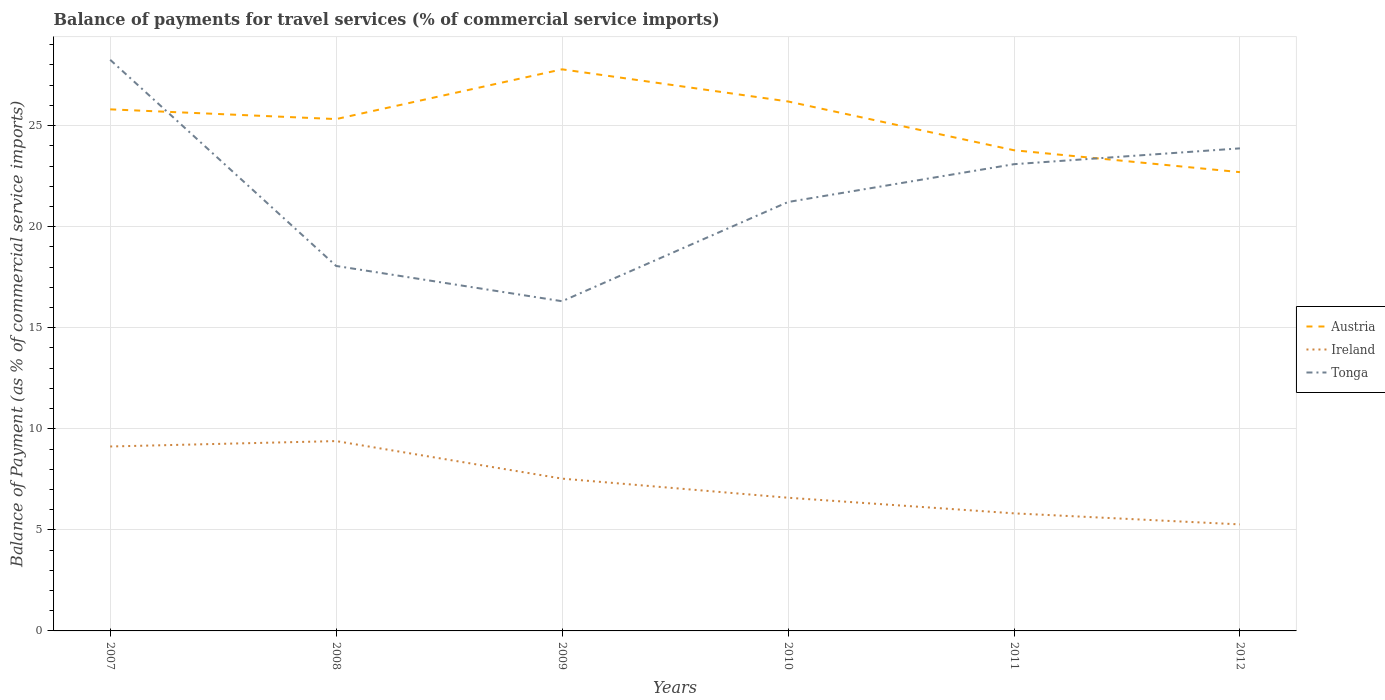Across all years, what is the maximum balance of payments for travel services in Ireland?
Your answer should be compact. 5.27. What is the total balance of payments for travel services in Austria in the graph?
Provide a succinct answer. 3.5. What is the difference between the highest and the second highest balance of payments for travel services in Austria?
Offer a terse response. 5.09. What is the difference between the highest and the lowest balance of payments for travel services in Austria?
Your response must be concise. 4. How many years are there in the graph?
Offer a terse response. 6. Are the values on the major ticks of Y-axis written in scientific E-notation?
Your answer should be compact. No. Does the graph contain any zero values?
Give a very brief answer. No. What is the title of the graph?
Your answer should be very brief. Balance of payments for travel services (% of commercial service imports). What is the label or title of the X-axis?
Your answer should be very brief. Years. What is the label or title of the Y-axis?
Make the answer very short. Balance of Payment (as % of commercial service imports). What is the Balance of Payment (as % of commercial service imports) in Austria in 2007?
Make the answer very short. 25.8. What is the Balance of Payment (as % of commercial service imports) in Ireland in 2007?
Give a very brief answer. 9.12. What is the Balance of Payment (as % of commercial service imports) of Tonga in 2007?
Provide a short and direct response. 28.25. What is the Balance of Payment (as % of commercial service imports) of Austria in 2008?
Offer a very short reply. 25.32. What is the Balance of Payment (as % of commercial service imports) in Ireland in 2008?
Ensure brevity in your answer.  9.39. What is the Balance of Payment (as % of commercial service imports) of Tonga in 2008?
Your answer should be very brief. 18.06. What is the Balance of Payment (as % of commercial service imports) of Austria in 2009?
Make the answer very short. 27.78. What is the Balance of Payment (as % of commercial service imports) of Ireland in 2009?
Ensure brevity in your answer.  7.53. What is the Balance of Payment (as % of commercial service imports) of Tonga in 2009?
Offer a very short reply. 16.31. What is the Balance of Payment (as % of commercial service imports) of Austria in 2010?
Offer a very short reply. 26.19. What is the Balance of Payment (as % of commercial service imports) of Ireland in 2010?
Make the answer very short. 6.59. What is the Balance of Payment (as % of commercial service imports) of Tonga in 2010?
Your answer should be very brief. 21.22. What is the Balance of Payment (as % of commercial service imports) of Austria in 2011?
Offer a terse response. 23.78. What is the Balance of Payment (as % of commercial service imports) of Ireland in 2011?
Give a very brief answer. 5.82. What is the Balance of Payment (as % of commercial service imports) in Tonga in 2011?
Keep it short and to the point. 23.09. What is the Balance of Payment (as % of commercial service imports) of Austria in 2012?
Provide a short and direct response. 22.7. What is the Balance of Payment (as % of commercial service imports) in Ireland in 2012?
Offer a very short reply. 5.27. What is the Balance of Payment (as % of commercial service imports) in Tonga in 2012?
Give a very brief answer. 23.87. Across all years, what is the maximum Balance of Payment (as % of commercial service imports) of Austria?
Your response must be concise. 27.78. Across all years, what is the maximum Balance of Payment (as % of commercial service imports) of Ireland?
Offer a very short reply. 9.39. Across all years, what is the maximum Balance of Payment (as % of commercial service imports) of Tonga?
Your response must be concise. 28.25. Across all years, what is the minimum Balance of Payment (as % of commercial service imports) in Austria?
Provide a short and direct response. 22.7. Across all years, what is the minimum Balance of Payment (as % of commercial service imports) in Ireland?
Make the answer very short. 5.27. Across all years, what is the minimum Balance of Payment (as % of commercial service imports) of Tonga?
Your answer should be compact. 16.31. What is the total Balance of Payment (as % of commercial service imports) in Austria in the graph?
Your answer should be very brief. 151.58. What is the total Balance of Payment (as % of commercial service imports) of Ireland in the graph?
Ensure brevity in your answer.  43.73. What is the total Balance of Payment (as % of commercial service imports) of Tonga in the graph?
Your response must be concise. 130.81. What is the difference between the Balance of Payment (as % of commercial service imports) in Austria in 2007 and that in 2008?
Make the answer very short. 0.48. What is the difference between the Balance of Payment (as % of commercial service imports) in Ireland in 2007 and that in 2008?
Offer a terse response. -0.27. What is the difference between the Balance of Payment (as % of commercial service imports) in Tonga in 2007 and that in 2008?
Your answer should be compact. 10.2. What is the difference between the Balance of Payment (as % of commercial service imports) in Austria in 2007 and that in 2009?
Offer a very short reply. -1.98. What is the difference between the Balance of Payment (as % of commercial service imports) of Ireland in 2007 and that in 2009?
Make the answer very short. 1.59. What is the difference between the Balance of Payment (as % of commercial service imports) in Tonga in 2007 and that in 2009?
Ensure brevity in your answer.  11.94. What is the difference between the Balance of Payment (as % of commercial service imports) in Austria in 2007 and that in 2010?
Offer a terse response. -0.39. What is the difference between the Balance of Payment (as % of commercial service imports) of Ireland in 2007 and that in 2010?
Your answer should be very brief. 2.54. What is the difference between the Balance of Payment (as % of commercial service imports) of Tonga in 2007 and that in 2010?
Provide a short and direct response. 7.03. What is the difference between the Balance of Payment (as % of commercial service imports) of Austria in 2007 and that in 2011?
Provide a succinct answer. 2.02. What is the difference between the Balance of Payment (as % of commercial service imports) in Ireland in 2007 and that in 2011?
Provide a succinct answer. 3.31. What is the difference between the Balance of Payment (as % of commercial service imports) in Tonga in 2007 and that in 2011?
Offer a terse response. 5.16. What is the difference between the Balance of Payment (as % of commercial service imports) of Austria in 2007 and that in 2012?
Offer a very short reply. 3.11. What is the difference between the Balance of Payment (as % of commercial service imports) in Ireland in 2007 and that in 2012?
Your answer should be compact. 3.85. What is the difference between the Balance of Payment (as % of commercial service imports) in Tonga in 2007 and that in 2012?
Provide a short and direct response. 4.38. What is the difference between the Balance of Payment (as % of commercial service imports) of Austria in 2008 and that in 2009?
Make the answer very short. -2.46. What is the difference between the Balance of Payment (as % of commercial service imports) of Ireland in 2008 and that in 2009?
Offer a very short reply. 1.86. What is the difference between the Balance of Payment (as % of commercial service imports) in Tonga in 2008 and that in 2009?
Provide a succinct answer. 1.74. What is the difference between the Balance of Payment (as % of commercial service imports) in Austria in 2008 and that in 2010?
Give a very brief answer. -0.87. What is the difference between the Balance of Payment (as % of commercial service imports) in Ireland in 2008 and that in 2010?
Make the answer very short. 2.8. What is the difference between the Balance of Payment (as % of commercial service imports) of Tonga in 2008 and that in 2010?
Offer a terse response. -3.16. What is the difference between the Balance of Payment (as % of commercial service imports) in Austria in 2008 and that in 2011?
Give a very brief answer. 1.54. What is the difference between the Balance of Payment (as % of commercial service imports) in Ireland in 2008 and that in 2011?
Give a very brief answer. 3.58. What is the difference between the Balance of Payment (as % of commercial service imports) of Tonga in 2008 and that in 2011?
Offer a terse response. -5.03. What is the difference between the Balance of Payment (as % of commercial service imports) of Austria in 2008 and that in 2012?
Keep it short and to the point. 2.63. What is the difference between the Balance of Payment (as % of commercial service imports) of Ireland in 2008 and that in 2012?
Keep it short and to the point. 4.12. What is the difference between the Balance of Payment (as % of commercial service imports) of Tonga in 2008 and that in 2012?
Give a very brief answer. -5.82. What is the difference between the Balance of Payment (as % of commercial service imports) in Austria in 2009 and that in 2010?
Ensure brevity in your answer.  1.59. What is the difference between the Balance of Payment (as % of commercial service imports) of Ireland in 2009 and that in 2010?
Your answer should be compact. 0.94. What is the difference between the Balance of Payment (as % of commercial service imports) in Tonga in 2009 and that in 2010?
Make the answer very short. -4.91. What is the difference between the Balance of Payment (as % of commercial service imports) in Austria in 2009 and that in 2011?
Keep it short and to the point. 4. What is the difference between the Balance of Payment (as % of commercial service imports) in Ireland in 2009 and that in 2011?
Your answer should be compact. 1.72. What is the difference between the Balance of Payment (as % of commercial service imports) of Tonga in 2009 and that in 2011?
Provide a succinct answer. -6.78. What is the difference between the Balance of Payment (as % of commercial service imports) in Austria in 2009 and that in 2012?
Offer a very short reply. 5.09. What is the difference between the Balance of Payment (as % of commercial service imports) in Ireland in 2009 and that in 2012?
Keep it short and to the point. 2.26. What is the difference between the Balance of Payment (as % of commercial service imports) in Tonga in 2009 and that in 2012?
Make the answer very short. -7.56. What is the difference between the Balance of Payment (as % of commercial service imports) of Austria in 2010 and that in 2011?
Offer a terse response. 2.41. What is the difference between the Balance of Payment (as % of commercial service imports) in Ireland in 2010 and that in 2011?
Offer a very short reply. 0.77. What is the difference between the Balance of Payment (as % of commercial service imports) of Tonga in 2010 and that in 2011?
Give a very brief answer. -1.87. What is the difference between the Balance of Payment (as % of commercial service imports) of Austria in 2010 and that in 2012?
Keep it short and to the point. 3.5. What is the difference between the Balance of Payment (as % of commercial service imports) of Ireland in 2010 and that in 2012?
Your answer should be very brief. 1.32. What is the difference between the Balance of Payment (as % of commercial service imports) of Tonga in 2010 and that in 2012?
Make the answer very short. -2.65. What is the difference between the Balance of Payment (as % of commercial service imports) of Austria in 2011 and that in 2012?
Your answer should be compact. 1.08. What is the difference between the Balance of Payment (as % of commercial service imports) of Ireland in 2011 and that in 2012?
Ensure brevity in your answer.  0.55. What is the difference between the Balance of Payment (as % of commercial service imports) in Tonga in 2011 and that in 2012?
Offer a terse response. -0.78. What is the difference between the Balance of Payment (as % of commercial service imports) in Austria in 2007 and the Balance of Payment (as % of commercial service imports) in Ireland in 2008?
Keep it short and to the point. 16.41. What is the difference between the Balance of Payment (as % of commercial service imports) in Austria in 2007 and the Balance of Payment (as % of commercial service imports) in Tonga in 2008?
Provide a succinct answer. 7.75. What is the difference between the Balance of Payment (as % of commercial service imports) of Ireland in 2007 and the Balance of Payment (as % of commercial service imports) of Tonga in 2008?
Keep it short and to the point. -8.93. What is the difference between the Balance of Payment (as % of commercial service imports) of Austria in 2007 and the Balance of Payment (as % of commercial service imports) of Ireland in 2009?
Your answer should be compact. 18.27. What is the difference between the Balance of Payment (as % of commercial service imports) of Austria in 2007 and the Balance of Payment (as % of commercial service imports) of Tonga in 2009?
Make the answer very short. 9.49. What is the difference between the Balance of Payment (as % of commercial service imports) of Ireland in 2007 and the Balance of Payment (as % of commercial service imports) of Tonga in 2009?
Offer a terse response. -7.19. What is the difference between the Balance of Payment (as % of commercial service imports) in Austria in 2007 and the Balance of Payment (as % of commercial service imports) in Ireland in 2010?
Ensure brevity in your answer.  19.21. What is the difference between the Balance of Payment (as % of commercial service imports) in Austria in 2007 and the Balance of Payment (as % of commercial service imports) in Tonga in 2010?
Keep it short and to the point. 4.58. What is the difference between the Balance of Payment (as % of commercial service imports) of Ireland in 2007 and the Balance of Payment (as % of commercial service imports) of Tonga in 2010?
Offer a very short reply. -12.1. What is the difference between the Balance of Payment (as % of commercial service imports) of Austria in 2007 and the Balance of Payment (as % of commercial service imports) of Ireland in 2011?
Keep it short and to the point. 19.99. What is the difference between the Balance of Payment (as % of commercial service imports) in Austria in 2007 and the Balance of Payment (as % of commercial service imports) in Tonga in 2011?
Keep it short and to the point. 2.71. What is the difference between the Balance of Payment (as % of commercial service imports) in Ireland in 2007 and the Balance of Payment (as % of commercial service imports) in Tonga in 2011?
Give a very brief answer. -13.97. What is the difference between the Balance of Payment (as % of commercial service imports) in Austria in 2007 and the Balance of Payment (as % of commercial service imports) in Ireland in 2012?
Your answer should be compact. 20.53. What is the difference between the Balance of Payment (as % of commercial service imports) of Austria in 2007 and the Balance of Payment (as % of commercial service imports) of Tonga in 2012?
Give a very brief answer. 1.93. What is the difference between the Balance of Payment (as % of commercial service imports) of Ireland in 2007 and the Balance of Payment (as % of commercial service imports) of Tonga in 2012?
Give a very brief answer. -14.75. What is the difference between the Balance of Payment (as % of commercial service imports) in Austria in 2008 and the Balance of Payment (as % of commercial service imports) in Ireland in 2009?
Offer a terse response. 17.79. What is the difference between the Balance of Payment (as % of commercial service imports) in Austria in 2008 and the Balance of Payment (as % of commercial service imports) in Tonga in 2009?
Provide a short and direct response. 9.01. What is the difference between the Balance of Payment (as % of commercial service imports) of Ireland in 2008 and the Balance of Payment (as % of commercial service imports) of Tonga in 2009?
Give a very brief answer. -6.92. What is the difference between the Balance of Payment (as % of commercial service imports) in Austria in 2008 and the Balance of Payment (as % of commercial service imports) in Ireland in 2010?
Provide a short and direct response. 18.73. What is the difference between the Balance of Payment (as % of commercial service imports) of Austria in 2008 and the Balance of Payment (as % of commercial service imports) of Tonga in 2010?
Give a very brief answer. 4.1. What is the difference between the Balance of Payment (as % of commercial service imports) in Ireland in 2008 and the Balance of Payment (as % of commercial service imports) in Tonga in 2010?
Give a very brief answer. -11.83. What is the difference between the Balance of Payment (as % of commercial service imports) of Austria in 2008 and the Balance of Payment (as % of commercial service imports) of Ireland in 2011?
Make the answer very short. 19.51. What is the difference between the Balance of Payment (as % of commercial service imports) in Austria in 2008 and the Balance of Payment (as % of commercial service imports) in Tonga in 2011?
Keep it short and to the point. 2.23. What is the difference between the Balance of Payment (as % of commercial service imports) of Ireland in 2008 and the Balance of Payment (as % of commercial service imports) of Tonga in 2011?
Offer a terse response. -13.7. What is the difference between the Balance of Payment (as % of commercial service imports) in Austria in 2008 and the Balance of Payment (as % of commercial service imports) in Ireland in 2012?
Your answer should be very brief. 20.05. What is the difference between the Balance of Payment (as % of commercial service imports) in Austria in 2008 and the Balance of Payment (as % of commercial service imports) in Tonga in 2012?
Your answer should be compact. 1.45. What is the difference between the Balance of Payment (as % of commercial service imports) in Ireland in 2008 and the Balance of Payment (as % of commercial service imports) in Tonga in 2012?
Your response must be concise. -14.48. What is the difference between the Balance of Payment (as % of commercial service imports) of Austria in 2009 and the Balance of Payment (as % of commercial service imports) of Ireland in 2010?
Your response must be concise. 21.19. What is the difference between the Balance of Payment (as % of commercial service imports) in Austria in 2009 and the Balance of Payment (as % of commercial service imports) in Tonga in 2010?
Ensure brevity in your answer.  6.56. What is the difference between the Balance of Payment (as % of commercial service imports) in Ireland in 2009 and the Balance of Payment (as % of commercial service imports) in Tonga in 2010?
Give a very brief answer. -13.69. What is the difference between the Balance of Payment (as % of commercial service imports) of Austria in 2009 and the Balance of Payment (as % of commercial service imports) of Ireland in 2011?
Provide a short and direct response. 21.97. What is the difference between the Balance of Payment (as % of commercial service imports) in Austria in 2009 and the Balance of Payment (as % of commercial service imports) in Tonga in 2011?
Your answer should be very brief. 4.69. What is the difference between the Balance of Payment (as % of commercial service imports) in Ireland in 2009 and the Balance of Payment (as % of commercial service imports) in Tonga in 2011?
Give a very brief answer. -15.56. What is the difference between the Balance of Payment (as % of commercial service imports) of Austria in 2009 and the Balance of Payment (as % of commercial service imports) of Ireland in 2012?
Make the answer very short. 22.51. What is the difference between the Balance of Payment (as % of commercial service imports) of Austria in 2009 and the Balance of Payment (as % of commercial service imports) of Tonga in 2012?
Ensure brevity in your answer.  3.91. What is the difference between the Balance of Payment (as % of commercial service imports) of Ireland in 2009 and the Balance of Payment (as % of commercial service imports) of Tonga in 2012?
Make the answer very short. -16.34. What is the difference between the Balance of Payment (as % of commercial service imports) in Austria in 2010 and the Balance of Payment (as % of commercial service imports) in Ireland in 2011?
Give a very brief answer. 20.38. What is the difference between the Balance of Payment (as % of commercial service imports) in Austria in 2010 and the Balance of Payment (as % of commercial service imports) in Tonga in 2011?
Your answer should be very brief. 3.1. What is the difference between the Balance of Payment (as % of commercial service imports) in Ireland in 2010 and the Balance of Payment (as % of commercial service imports) in Tonga in 2011?
Ensure brevity in your answer.  -16.5. What is the difference between the Balance of Payment (as % of commercial service imports) of Austria in 2010 and the Balance of Payment (as % of commercial service imports) of Ireland in 2012?
Offer a terse response. 20.92. What is the difference between the Balance of Payment (as % of commercial service imports) of Austria in 2010 and the Balance of Payment (as % of commercial service imports) of Tonga in 2012?
Your answer should be very brief. 2.32. What is the difference between the Balance of Payment (as % of commercial service imports) in Ireland in 2010 and the Balance of Payment (as % of commercial service imports) in Tonga in 2012?
Your answer should be very brief. -17.28. What is the difference between the Balance of Payment (as % of commercial service imports) in Austria in 2011 and the Balance of Payment (as % of commercial service imports) in Ireland in 2012?
Offer a very short reply. 18.51. What is the difference between the Balance of Payment (as % of commercial service imports) in Austria in 2011 and the Balance of Payment (as % of commercial service imports) in Tonga in 2012?
Offer a terse response. -0.09. What is the difference between the Balance of Payment (as % of commercial service imports) of Ireland in 2011 and the Balance of Payment (as % of commercial service imports) of Tonga in 2012?
Your response must be concise. -18.06. What is the average Balance of Payment (as % of commercial service imports) in Austria per year?
Your answer should be compact. 25.26. What is the average Balance of Payment (as % of commercial service imports) of Ireland per year?
Offer a terse response. 7.29. What is the average Balance of Payment (as % of commercial service imports) of Tonga per year?
Your answer should be very brief. 21.8. In the year 2007, what is the difference between the Balance of Payment (as % of commercial service imports) in Austria and Balance of Payment (as % of commercial service imports) in Ireland?
Ensure brevity in your answer.  16.68. In the year 2007, what is the difference between the Balance of Payment (as % of commercial service imports) of Austria and Balance of Payment (as % of commercial service imports) of Tonga?
Your response must be concise. -2.45. In the year 2007, what is the difference between the Balance of Payment (as % of commercial service imports) of Ireland and Balance of Payment (as % of commercial service imports) of Tonga?
Keep it short and to the point. -19.13. In the year 2008, what is the difference between the Balance of Payment (as % of commercial service imports) in Austria and Balance of Payment (as % of commercial service imports) in Ireland?
Offer a terse response. 15.93. In the year 2008, what is the difference between the Balance of Payment (as % of commercial service imports) in Austria and Balance of Payment (as % of commercial service imports) in Tonga?
Offer a very short reply. 7.27. In the year 2008, what is the difference between the Balance of Payment (as % of commercial service imports) of Ireland and Balance of Payment (as % of commercial service imports) of Tonga?
Make the answer very short. -8.66. In the year 2009, what is the difference between the Balance of Payment (as % of commercial service imports) of Austria and Balance of Payment (as % of commercial service imports) of Ireland?
Offer a very short reply. 20.25. In the year 2009, what is the difference between the Balance of Payment (as % of commercial service imports) of Austria and Balance of Payment (as % of commercial service imports) of Tonga?
Your answer should be very brief. 11.47. In the year 2009, what is the difference between the Balance of Payment (as % of commercial service imports) of Ireland and Balance of Payment (as % of commercial service imports) of Tonga?
Make the answer very short. -8.78. In the year 2010, what is the difference between the Balance of Payment (as % of commercial service imports) of Austria and Balance of Payment (as % of commercial service imports) of Ireland?
Offer a very short reply. 19.6. In the year 2010, what is the difference between the Balance of Payment (as % of commercial service imports) in Austria and Balance of Payment (as % of commercial service imports) in Tonga?
Ensure brevity in your answer.  4.97. In the year 2010, what is the difference between the Balance of Payment (as % of commercial service imports) of Ireland and Balance of Payment (as % of commercial service imports) of Tonga?
Provide a succinct answer. -14.63. In the year 2011, what is the difference between the Balance of Payment (as % of commercial service imports) of Austria and Balance of Payment (as % of commercial service imports) of Ireland?
Offer a terse response. 17.96. In the year 2011, what is the difference between the Balance of Payment (as % of commercial service imports) of Austria and Balance of Payment (as % of commercial service imports) of Tonga?
Your response must be concise. 0.69. In the year 2011, what is the difference between the Balance of Payment (as % of commercial service imports) in Ireland and Balance of Payment (as % of commercial service imports) in Tonga?
Give a very brief answer. -17.27. In the year 2012, what is the difference between the Balance of Payment (as % of commercial service imports) of Austria and Balance of Payment (as % of commercial service imports) of Ireland?
Offer a very short reply. 17.43. In the year 2012, what is the difference between the Balance of Payment (as % of commercial service imports) in Austria and Balance of Payment (as % of commercial service imports) in Tonga?
Your answer should be very brief. -1.18. In the year 2012, what is the difference between the Balance of Payment (as % of commercial service imports) in Ireland and Balance of Payment (as % of commercial service imports) in Tonga?
Your answer should be very brief. -18.6. What is the ratio of the Balance of Payment (as % of commercial service imports) in Austria in 2007 to that in 2008?
Your answer should be very brief. 1.02. What is the ratio of the Balance of Payment (as % of commercial service imports) in Ireland in 2007 to that in 2008?
Your response must be concise. 0.97. What is the ratio of the Balance of Payment (as % of commercial service imports) in Tonga in 2007 to that in 2008?
Offer a very short reply. 1.56. What is the ratio of the Balance of Payment (as % of commercial service imports) of Austria in 2007 to that in 2009?
Your response must be concise. 0.93. What is the ratio of the Balance of Payment (as % of commercial service imports) of Ireland in 2007 to that in 2009?
Make the answer very short. 1.21. What is the ratio of the Balance of Payment (as % of commercial service imports) in Tonga in 2007 to that in 2009?
Your answer should be very brief. 1.73. What is the ratio of the Balance of Payment (as % of commercial service imports) of Austria in 2007 to that in 2010?
Offer a very short reply. 0.99. What is the ratio of the Balance of Payment (as % of commercial service imports) of Ireland in 2007 to that in 2010?
Give a very brief answer. 1.38. What is the ratio of the Balance of Payment (as % of commercial service imports) of Tonga in 2007 to that in 2010?
Make the answer very short. 1.33. What is the ratio of the Balance of Payment (as % of commercial service imports) in Austria in 2007 to that in 2011?
Offer a terse response. 1.09. What is the ratio of the Balance of Payment (as % of commercial service imports) of Ireland in 2007 to that in 2011?
Your response must be concise. 1.57. What is the ratio of the Balance of Payment (as % of commercial service imports) in Tonga in 2007 to that in 2011?
Keep it short and to the point. 1.22. What is the ratio of the Balance of Payment (as % of commercial service imports) in Austria in 2007 to that in 2012?
Your answer should be very brief. 1.14. What is the ratio of the Balance of Payment (as % of commercial service imports) of Ireland in 2007 to that in 2012?
Offer a terse response. 1.73. What is the ratio of the Balance of Payment (as % of commercial service imports) of Tonga in 2007 to that in 2012?
Give a very brief answer. 1.18. What is the ratio of the Balance of Payment (as % of commercial service imports) of Austria in 2008 to that in 2009?
Provide a succinct answer. 0.91. What is the ratio of the Balance of Payment (as % of commercial service imports) of Ireland in 2008 to that in 2009?
Give a very brief answer. 1.25. What is the ratio of the Balance of Payment (as % of commercial service imports) in Tonga in 2008 to that in 2009?
Ensure brevity in your answer.  1.11. What is the ratio of the Balance of Payment (as % of commercial service imports) of Austria in 2008 to that in 2010?
Provide a succinct answer. 0.97. What is the ratio of the Balance of Payment (as % of commercial service imports) in Ireland in 2008 to that in 2010?
Your response must be concise. 1.43. What is the ratio of the Balance of Payment (as % of commercial service imports) of Tonga in 2008 to that in 2010?
Your answer should be very brief. 0.85. What is the ratio of the Balance of Payment (as % of commercial service imports) of Austria in 2008 to that in 2011?
Offer a terse response. 1.06. What is the ratio of the Balance of Payment (as % of commercial service imports) of Ireland in 2008 to that in 2011?
Make the answer very short. 1.61. What is the ratio of the Balance of Payment (as % of commercial service imports) in Tonga in 2008 to that in 2011?
Your answer should be compact. 0.78. What is the ratio of the Balance of Payment (as % of commercial service imports) in Austria in 2008 to that in 2012?
Make the answer very short. 1.12. What is the ratio of the Balance of Payment (as % of commercial service imports) of Ireland in 2008 to that in 2012?
Your answer should be very brief. 1.78. What is the ratio of the Balance of Payment (as % of commercial service imports) in Tonga in 2008 to that in 2012?
Ensure brevity in your answer.  0.76. What is the ratio of the Balance of Payment (as % of commercial service imports) in Austria in 2009 to that in 2010?
Ensure brevity in your answer.  1.06. What is the ratio of the Balance of Payment (as % of commercial service imports) of Ireland in 2009 to that in 2010?
Your answer should be very brief. 1.14. What is the ratio of the Balance of Payment (as % of commercial service imports) of Tonga in 2009 to that in 2010?
Ensure brevity in your answer.  0.77. What is the ratio of the Balance of Payment (as % of commercial service imports) of Austria in 2009 to that in 2011?
Make the answer very short. 1.17. What is the ratio of the Balance of Payment (as % of commercial service imports) of Ireland in 2009 to that in 2011?
Provide a short and direct response. 1.3. What is the ratio of the Balance of Payment (as % of commercial service imports) in Tonga in 2009 to that in 2011?
Ensure brevity in your answer.  0.71. What is the ratio of the Balance of Payment (as % of commercial service imports) in Austria in 2009 to that in 2012?
Offer a very short reply. 1.22. What is the ratio of the Balance of Payment (as % of commercial service imports) in Ireland in 2009 to that in 2012?
Give a very brief answer. 1.43. What is the ratio of the Balance of Payment (as % of commercial service imports) in Tonga in 2009 to that in 2012?
Your answer should be compact. 0.68. What is the ratio of the Balance of Payment (as % of commercial service imports) in Austria in 2010 to that in 2011?
Your answer should be very brief. 1.1. What is the ratio of the Balance of Payment (as % of commercial service imports) in Ireland in 2010 to that in 2011?
Provide a succinct answer. 1.13. What is the ratio of the Balance of Payment (as % of commercial service imports) of Tonga in 2010 to that in 2011?
Provide a succinct answer. 0.92. What is the ratio of the Balance of Payment (as % of commercial service imports) of Austria in 2010 to that in 2012?
Make the answer very short. 1.15. What is the ratio of the Balance of Payment (as % of commercial service imports) in Ireland in 2010 to that in 2012?
Make the answer very short. 1.25. What is the ratio of the Balance of Payment (as % of commercial service imports) in Tonga in 2010 to that in 2012?
Your response must be concise. 0.89. What is the ratio of the Balance of Payment (as % of commercial service imports) in Austria in 2011 to that in 2012?
Your response must be concise. 1.05. What is the ratio of the Balance of Payment (as % of commercial service imports) of Ireland in 2011 to that in 2012?
Offer a terse response. 1.1. What is the ratio of the Balance of Payment (as % of commercial service imports) in Tonga in 2011 to that in 2012?
Offer a very short reply. 0.97. What is the difference between the highest and the second highest Balance of Payment (as % of commercial service imports) of Austria?
Offer a very short reply. 1.59. What is the difference between the highest and the second highest Balance of Payment (as % of commercial service imports) in Ireland?
Your answer should be compact. 0.27. What is the difference between the highest and the second highest Balance of Payment (as % of commercial service imports) of Tonga?
Provide a succinct answer. 4.38. What is the difference between the highest and the lowest Balance of Payment (as % of commercial service imports) in Austria?
Provide a succinct answer. 5.09. What is the difference between the highest and the lowest Balance of Payment (as % of commercial service imports) in Ireland?
Offer a very short reply. 4.12. What is the difference between the highest and the lowest Balance of Payment (as % of commercial service imports) of Tonga?
Give a very brief answer. 11.94. 